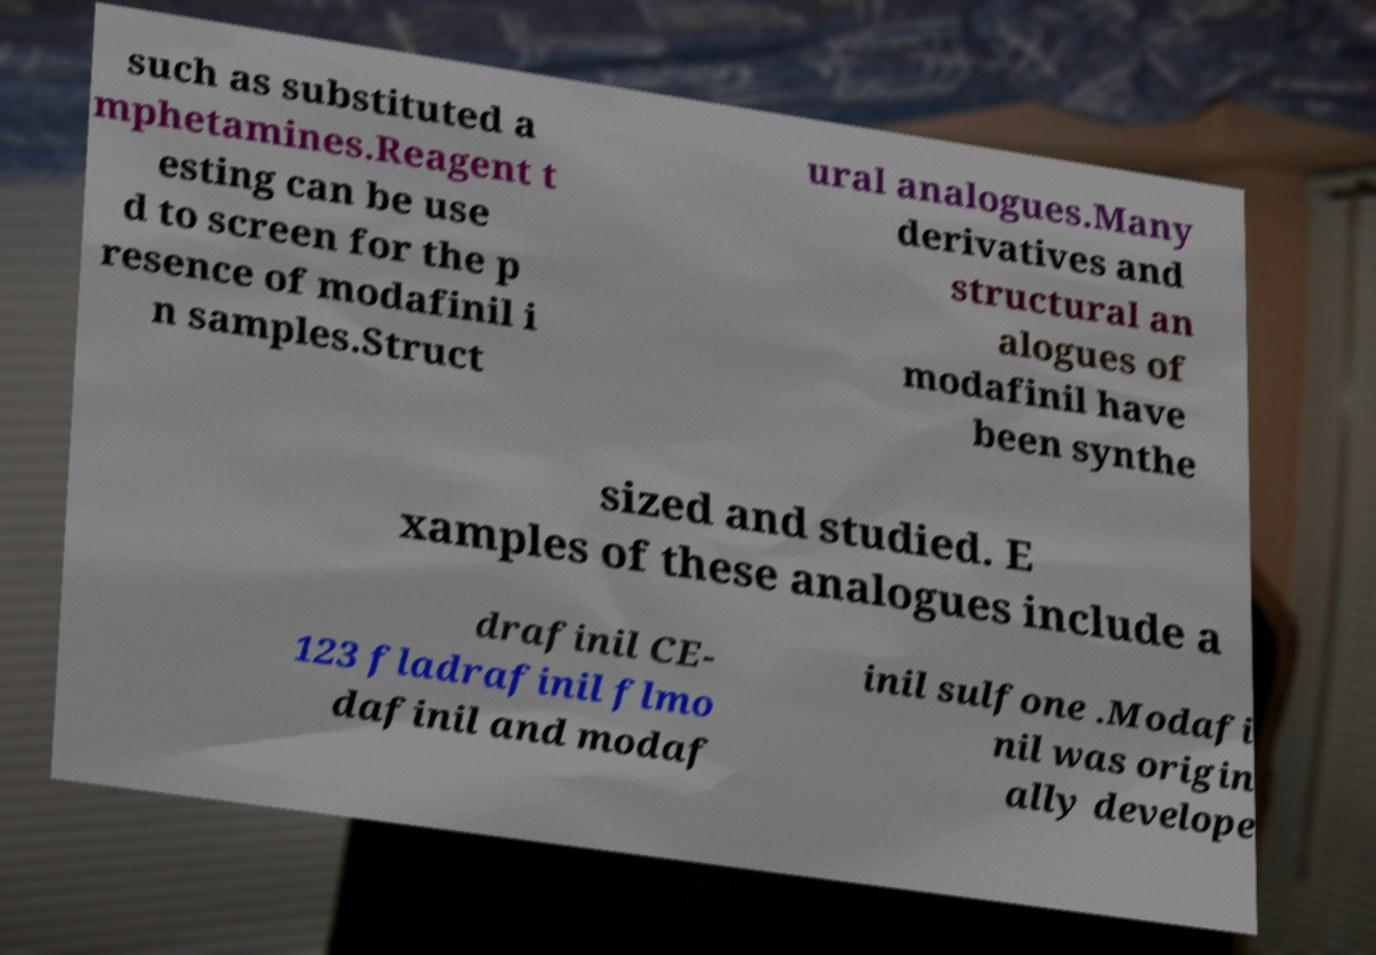What messages or text are displayed in this image? I need them in a readable, typed format. such as substituted a mphetamines.Reagent t esting can be use d to screen for the p resence of modafinil i n samples.Struct ural analogues.Many derivatives and structural an alogues of modafinil have been synthe sized and studied. E xamples of these analogues include a drafinil CE- 123 fladrafinil flmo dafinil and modaf inil sulfone .Modafi nil was origin ally develope 